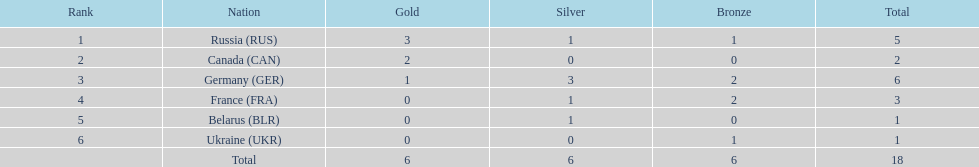What was the combined sum of silver medals awarded to the french and the germans in the 1994 winter olympic biathlon? 4. 